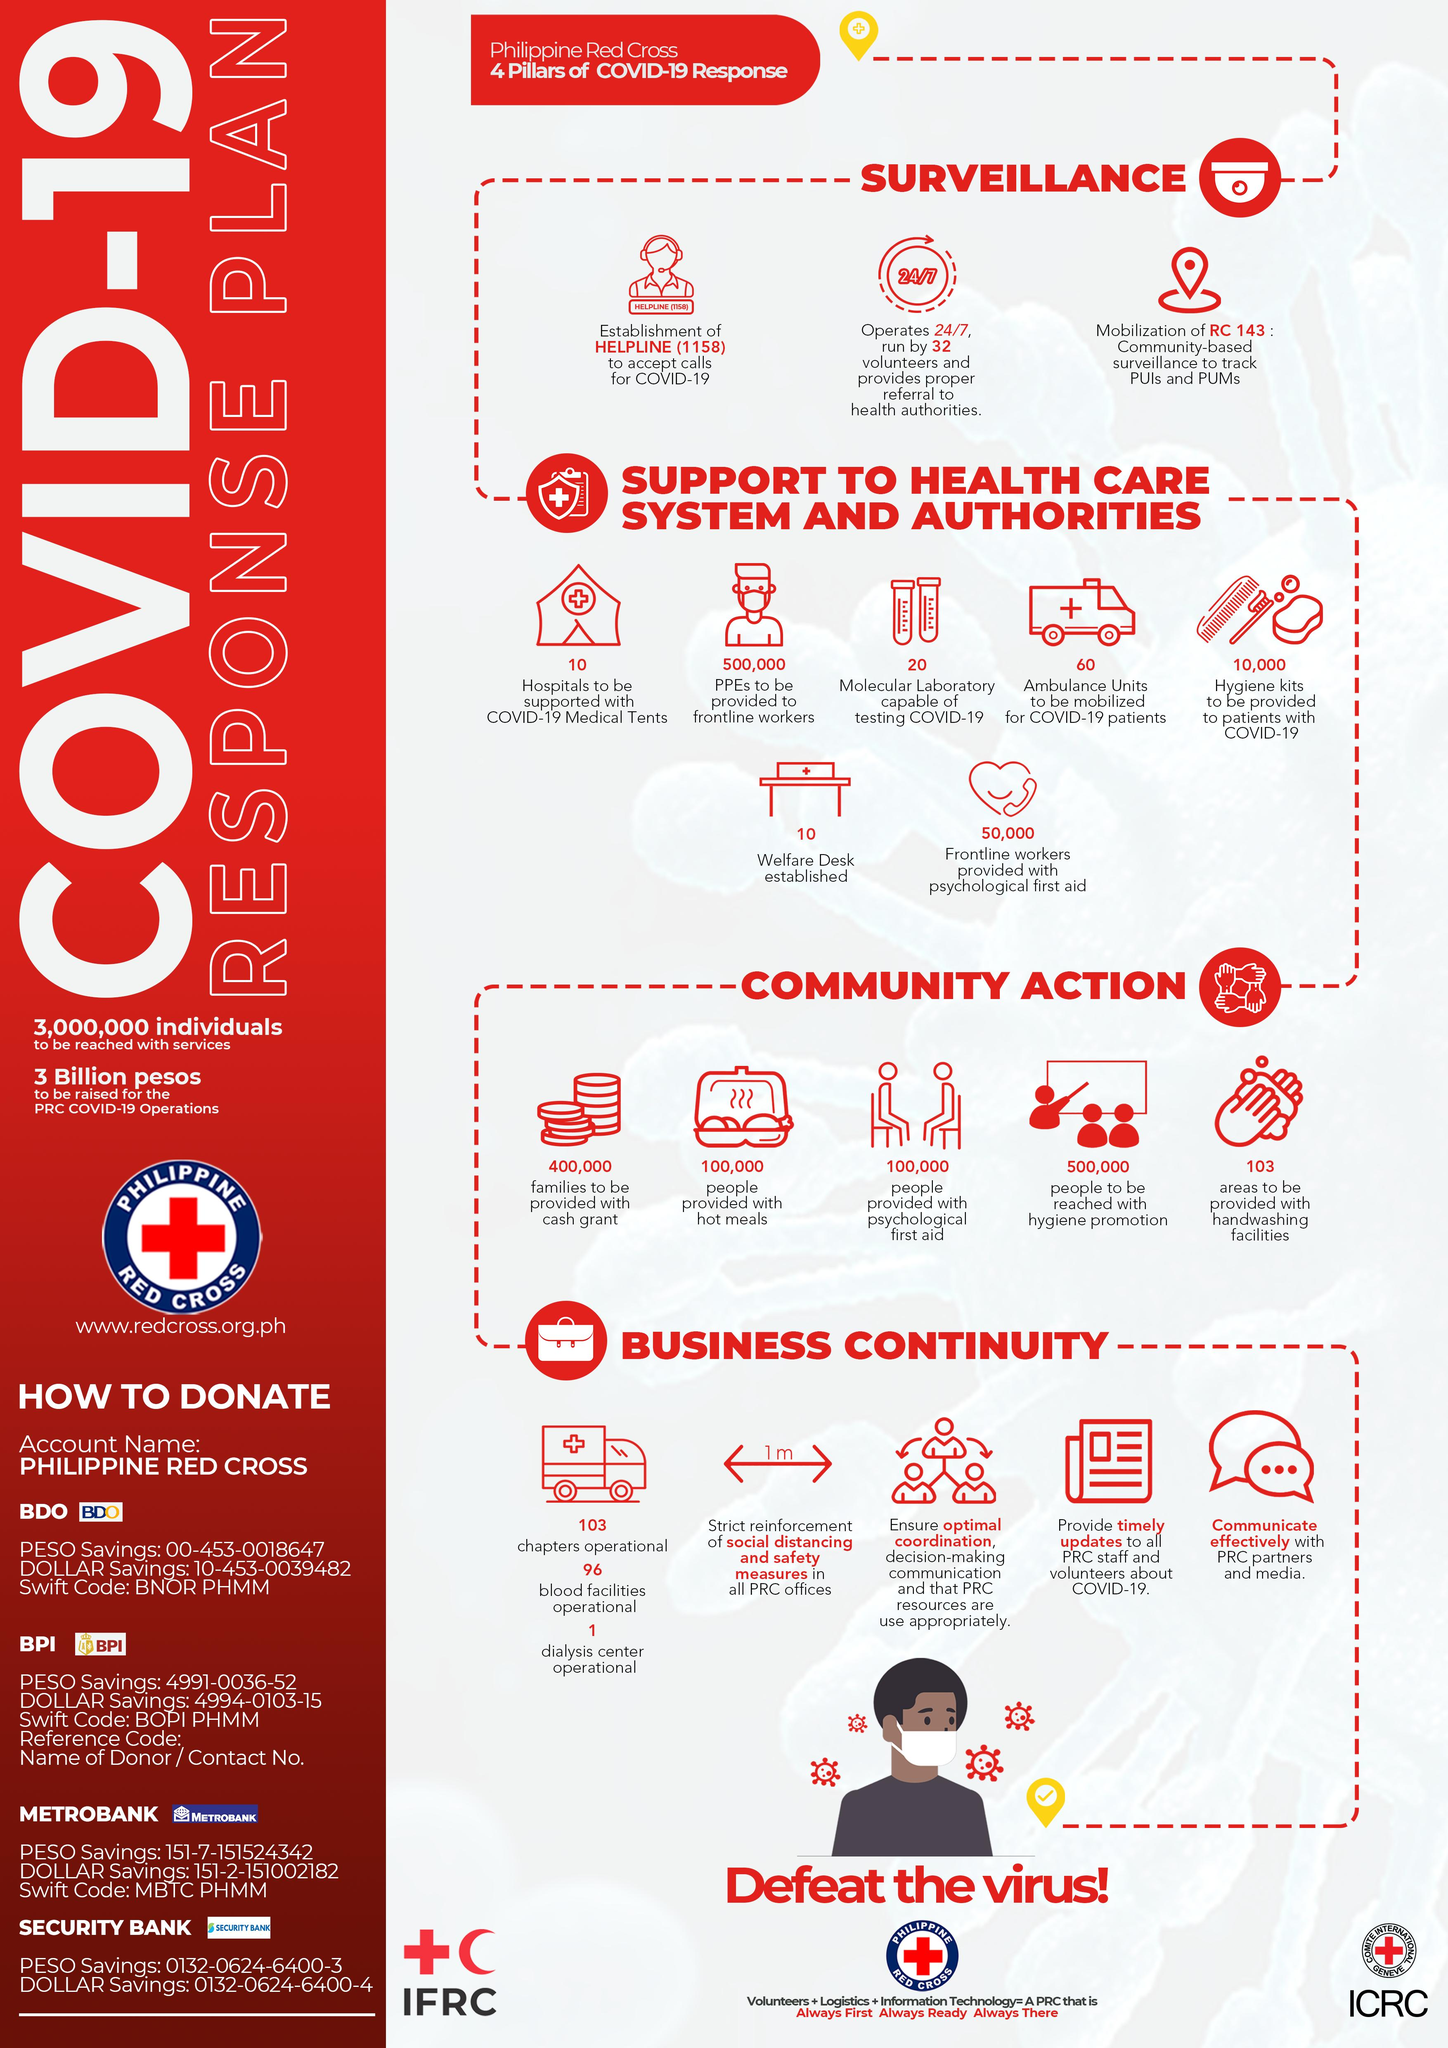Point out several critical features in this image. The Philippine Red Cross is planning to mobilize 60 ambulance units to respond to COVID-19 patients. According to the Philippine Red Cross, a total of 103 areas are required to be equipped with hand washing facilities. The Philippine Red Cross will provide cash grants to 400,000 families. The Philippine Red Cross will provide 500,000 Personal Protective Equipment (PPEs) to frontline workers. The Philippine Red Cross has provided psychological first aid to over 100,000 people. 